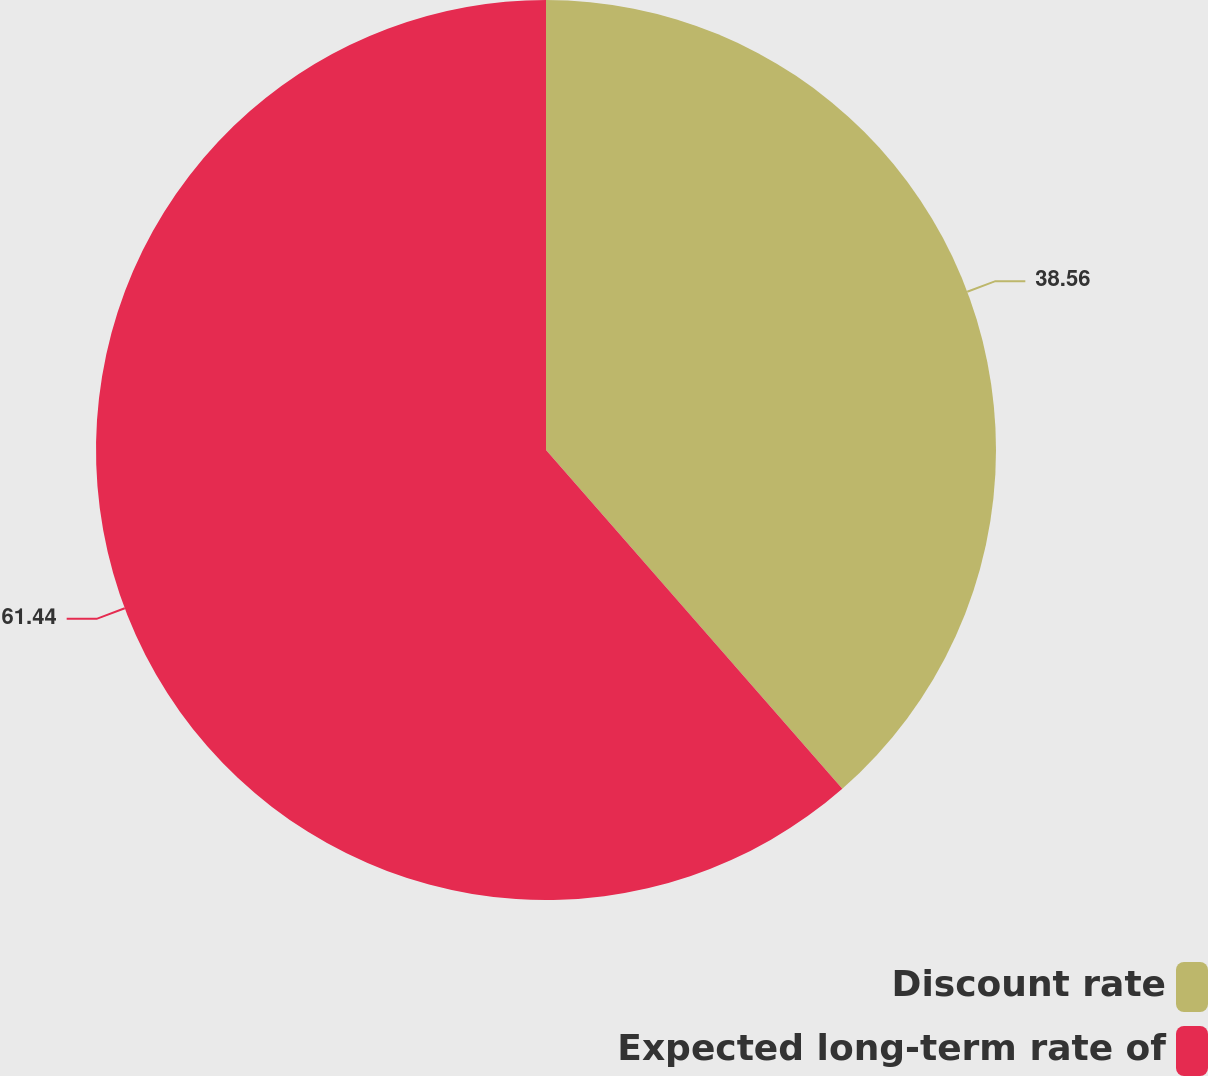Convert chart to OTSL. <chart><loc_0><loc_0><loc_500><loc_500><pie_chart><fcel>Discount rate<fcel>Expected long-term rate of<nl><fcel>38.56%<fcel>61.44%<nl></chart> 